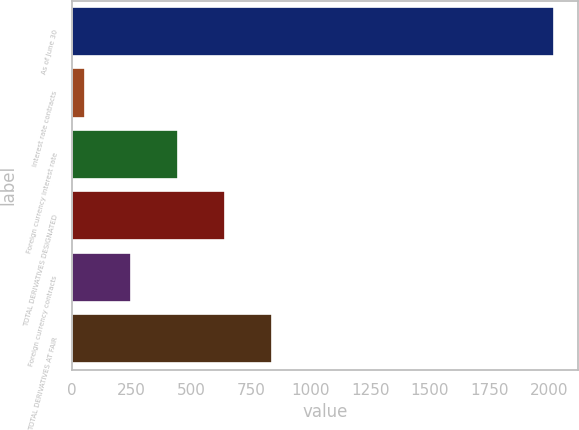Convert chart to OTSL. <chart><loc_0><loc_0><loc_500><loc_500><bar_chart><fcel>As of June 30<fcel>Interest rate contracts<fcel>Foreign currency interest rate<fcel>TOTAL DERIVATIVES DESIGNATED<fcel>Foreign currency contracts<fcel>TOTAL DERIVATIVES AT FAIR<nl><fcel>2018<fcel>53<fcel>446<fcel>642.5<fcel>249.5<fcel>839<nl></chart> 